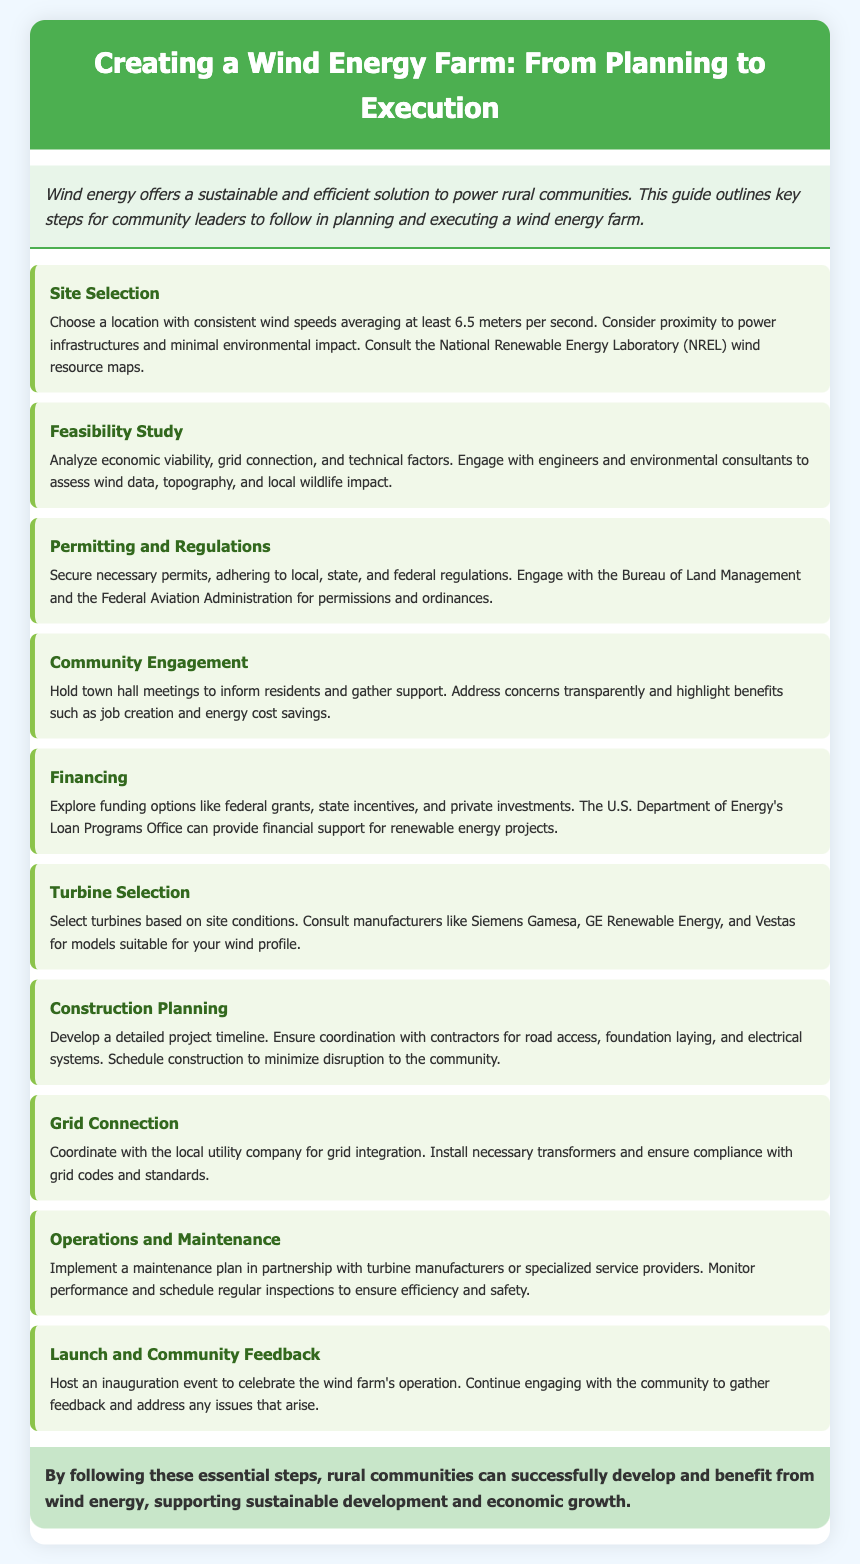What is the average wind speed for site selection? The average wind speed needed for site selection is mentioned in the document.
Answer: 6.5 meters per second Which organization provides wind resource maps? The document specifies the National Renewable Energy Laboratory as a source for wind resource maps.
Answer: National Renewable Energy Laboratory (NREL) What is the focus of community engagement according to the document? The document emphasizes informing residents and gathering support during community engagement.
Answer: Inform residents and gather support What type of funding options should be explored for financing? The document lists various funding sources for financing, including federal grants and state incentives.
Answer: Federal grants, state incentives What should be included in the operations and maintenance plan? The operations and maintenance plan must have regular inspections to ensure efficiency and safety.
Answer: Regular inspections What is the concluding goal of developing a wind energy farm? The conclusion of the document states the primary goal of developing a wind energy farm.
Answer: Sustainable development and economic growth 